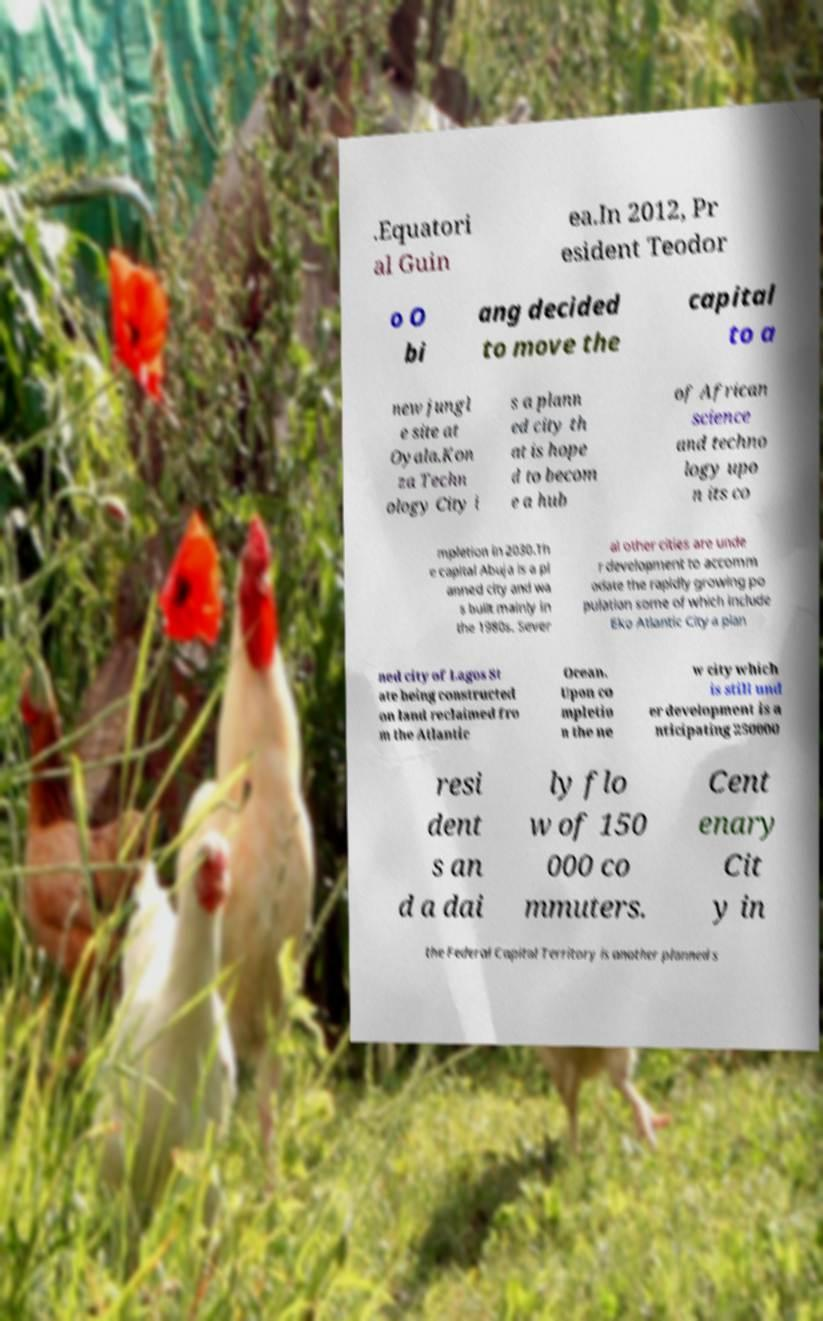What messages or text are displayed in this image? I need them in a readable, typed format. .Equatori al Guin ea.In 2012, Pr esident Teodor o O bi ang decided to move the capital to a new jungl e site at Oyala.Kon za Techn ology City i s a plann ed city th at is hope d to becom e a hub of African science and techno logy upo n its co mpletion in 2030.Th e capital Abuja is a pl anned city and wa s built mainly in the 1980s. Sever al other cities are unde r development to accomm odate the rapidly growing po pulation some of which include Eko Atlantic City a plan ned city of Lagos St ate being constructed on land reclaimed fro m the Atlantic Ocean. Upon co mpletio n the ne w city which is still und er development is a nticipating 250000 resi dent s an d a dai ly flo w of 150 000 co mmuters. Cent enary Cit y in the Federal Capital Territory is another planned s 